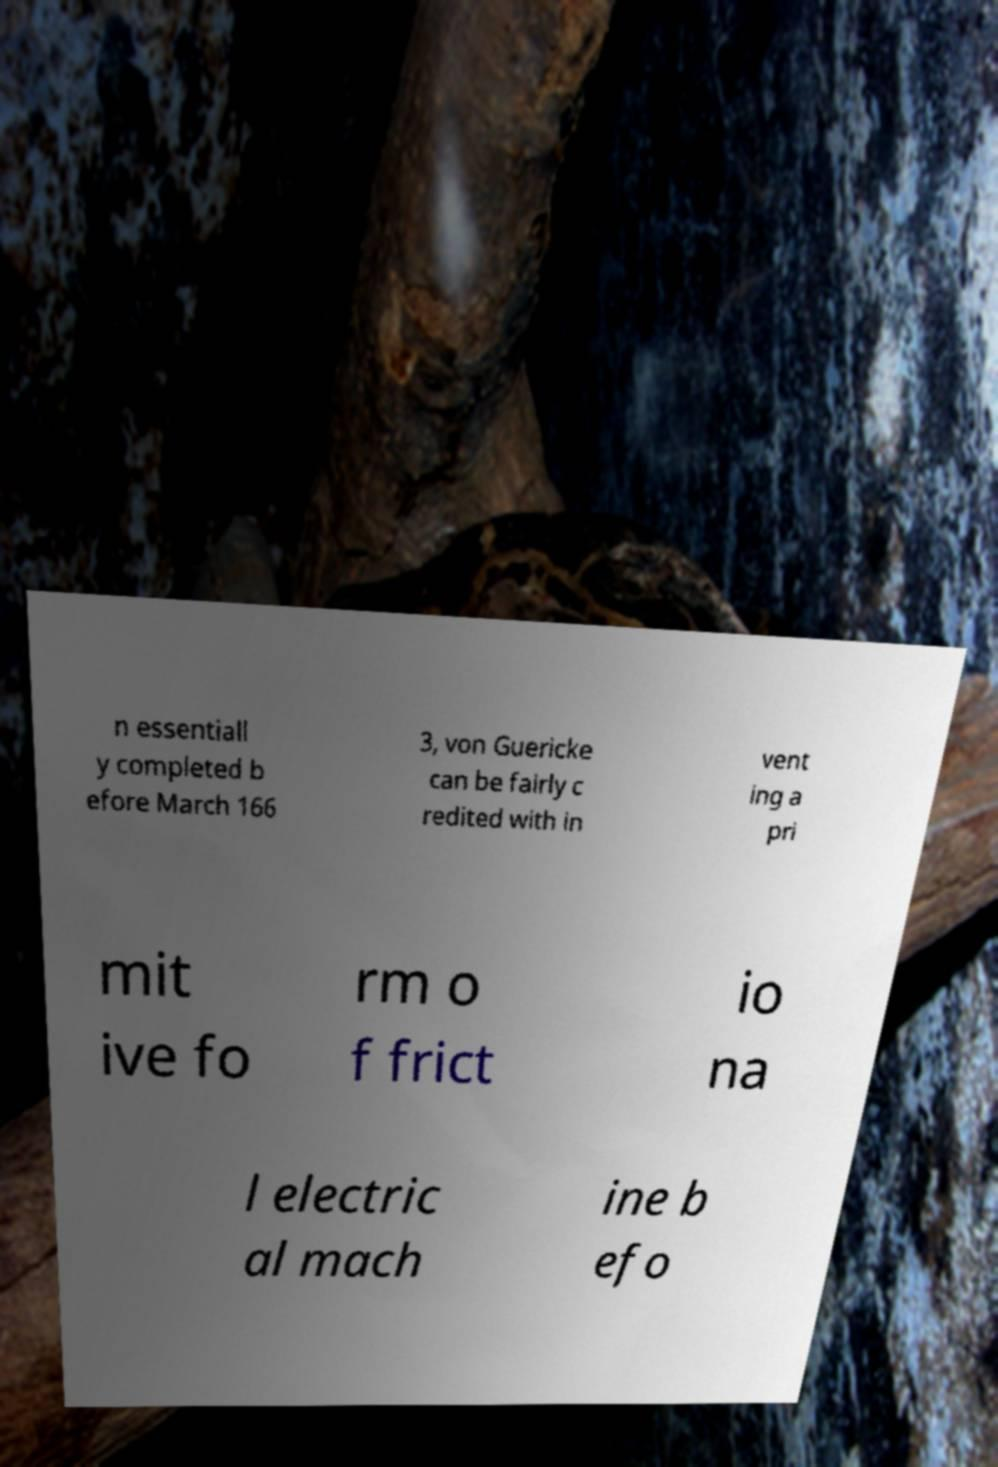Could you assist in decoding the text presented in this image and type it out clearly? n essentiall y completed b efore March 166 3, von Guericke can be fairly c redited with in vent ing a pri mit ive fo rm o f frict io na l electric al mach ine b efo 